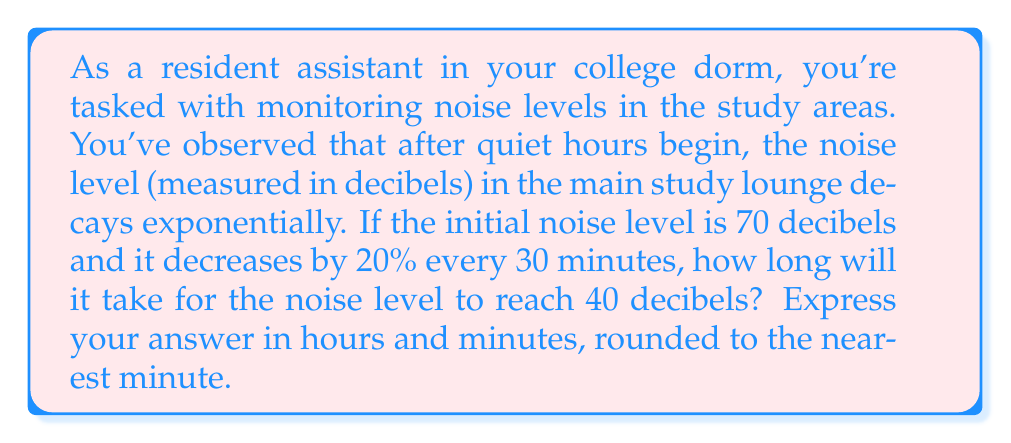Solve this math problem. Let's approach this step-by-step using an exponential decay model:

1) Let $N(t)$ be the noise level in decibels at time $t$ (in hours).

2) The initial condition is $N(0) = 70$ decibels.

3) The decay rate $r$ can be found from the given information:
   After 0.5 hours (30 minutes), the noise level is 80% of the original.
   $$0.8 = e^{-0.5r}$$
   $$\ln(0.8) = -0.5r$$
   $$r = -\frac{2\ln(0.8)}{1} \approx 0.4463$$

4) Our exponential decay model is:
   $$N(t) = 70e^{-0.4463t}$$

5) We want to find $t$ when $N(t) = 40$:
   $$40 = 70e^{-0.4463t}$$

6) Solving for $t$:
   $$\frac{40}{70} = e^{-0.4463t}$$
   $$\ln(\frac{40}{70}) = -0.4463t$$
   $$t = -\frac{\ln(\frac{40}{70})}{0.4463} \approx 1.3316$$

7) Converting to hours and minutes:
   1.3316 hours = 1 hour and 0.3316 * 60 ≈ 20 minutes

Therefore, it will take approximately 1 hour and 20 minutes for the noise level to reach 40 decibels.
Answer: 1 hour and 20 minutes 